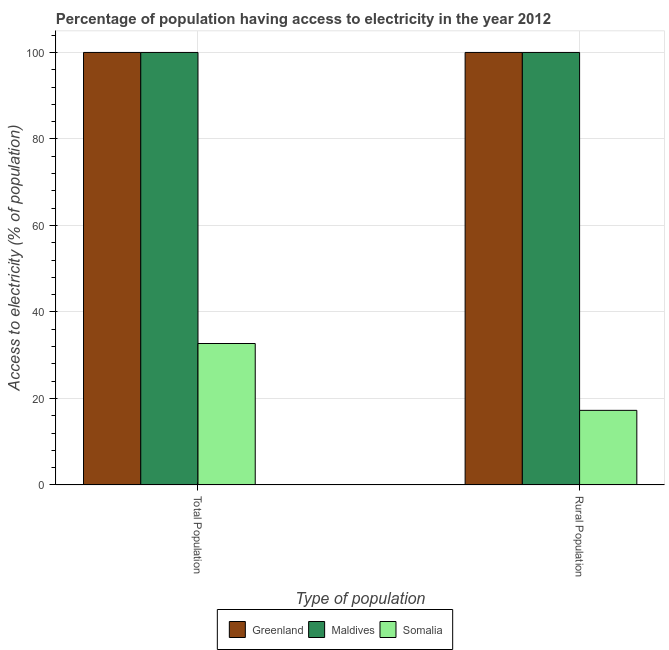How many groups of bars are there?
Provide a succinct answer. 2. Are the number of bars per tick equal to the number of legend labels?
Offer a very short reply. Yes. Are the number of bars on each tick of the X-axis equal?
Your answer should be compact. Yes. How many bars are there on the 2nd tick from the left?
Provide a succinct answer. 3. How many bars are there on the 2nd tick from the right?
Keep it short and to the point. 3. What is the label of the 2nd group of bars from the left?
Ensure brevity in your answer.  Rural Population. What is the percentage of population having access to electricity in Maldives?
Provide a succinct answer. 100. Across all countries, what is the minimum percentage of rural population having access to electricity?
Keep it short and to the point. 17.25. In which country was the percentage of rural population having access to electricity maximum?
Provide a succinct answer. Greenland. In which country was the percentage of rural population having access to electricity minimum?
Give a very brief answer. Somalia. What is the total percentage of rural population having access to electricity in the graph?
Your answer should be compact. 217.25. What is the difference between the percentage of population having access to electricity in Somalia and that in Maldives?
Give a very brief answer. -67.29. What is the difference between the percentage of population having access to electricity in Somalia and the percentage of rural population having access to electricity in Maldives?
Make the answer very short. -67.29. What is the average percentage of rural population having access to electricity per country?
Offer a terse response. 72.42. In how many countries, is the percentage of rural population having access to electricity greater than 48 %?
Offer a terse response. 2. What is the ratio of the percentage of rural population having access to electricity in Somalia to that in Greenland?
Your answer should be very brief. 0.17. Is the percentage of population having access to electricity in Maldives less than that in Somalia?
Ensure brevity in your answer.  No. What does the 1st bar from the left in Rural Population represents?
Your answer should be compact. Greenland. What does the 3rd bar from the right in Total Population represents?
Keep it short and to the point. Greenland. Are all the bars in the graph horizontal?
Give a very brief answer. No. Does the graph contain any zero values?
Make the answer very short. No. Where does the legend appear in the graph?
Keep it short and to the point. Bottom center. What is the title of the graph?
Your answer should be compact. Percentage of population having access to electricity in the year 2012. Does "Ireland" appear as one of the legend labels in the graph?
Make the answer very short. No. What is the label or title of the X-axis?
Your answer should be very brief. Type of population. What is the label or title of the Y-axis?
Ensure brevity in your answer.  Access to electricity (% of population). What is the Access to electricity (% of population) in Somalia in Total Population?
Keep it short and to the point. 32.71. What is the Access to electricity (% of population) in Somalia in Rural Population?
Make the answer very short. 17.25. Across all Type of population, what is the maximum Access to electricity (% of population) of Maldives?
Your response must be concise. 100. Across all Type of population, what is the maximum Access to electricity (% of population) in Somalia?
Offer a terse response. 32.71. Across all Type of population, what is the minimum Access to electricity (% of population) in Somalia?
Your answer should be very brief. 17.25. What is the total Access to electricity (% of population) of Maldives in the graph?
Offer a terse response. 200. What is the total Access to electricity (% of population) in Somalia in the graph?
Your answer should be very brief. 49.96. What is the difference between the Access to electricity (% of population) in Greenland in Total Population and that in Rural Population?
Ensure brevity in your answer.  0. What is the difference between the Access to electricity (% of population) of Somalia in Total Population and that in Rural Population?
Your response must be concise. 15.45. What is the difference between the Access to electricity (% of population) of Greenland in Total Population and the Access to electricity (% of population) of Somalia in Rural Population?
Your response must be concise. 82.75. What is the difference between the Access to electricity (% of population) of Maldives in Total Population and the Access to electricity (% of population) of Somalia in Rural Population?
Ensure brevity in your answer.  82.75. What is the average Access to electricity (% of population) of Maldives per Type of population?
Offer a very short reply. 100. What is the average Access to electricity (% of population) in Somalia per Type of population?
Make the answer very short. 24.98. What is the difference between the Access to electricity (% of population) in Greenland and Access to electricity (% of population) in Somalia in Total Population?
Your response must be concise. 67.29. What is the difference between the Access to electricity (% of population) of Maldives and Access to electricity (% of population) of Somalia in Total Population?
Your response must be concise. 67.29. What is the difference between the Access to electricity (% of population) in Greenland and Access to electricity (% of population) in Somalia in Rural Population?
Your response must be concise. 82.75. What is the difference between the Access to electricity (% of population) of Maldives and Access to electricity (% of population) of Somalia in Rural Population?
Your response must be concise. 82.75. What is the ratio of the Access to electricity (% of population) of Somalia in Total Population to that in Rural Population?
Give a very brief answer. 1.9. What is the difference between the highest and the second highest Access to electricity (% of population) of Greenland?
Your answer should be very brief. 0. What is the difference between the highest and the second highest Access to electricity (% of population) of Maldives?
Make the answer very short. 0. What is the difference between the highest and the second highest Access to electricity (% of population) of Somalia?
Offer a terse response. 15.45. What is the difference between the highest and the lowest Access to electricity (% of population) in Somalia?
Your response must be concise. 15.45. 